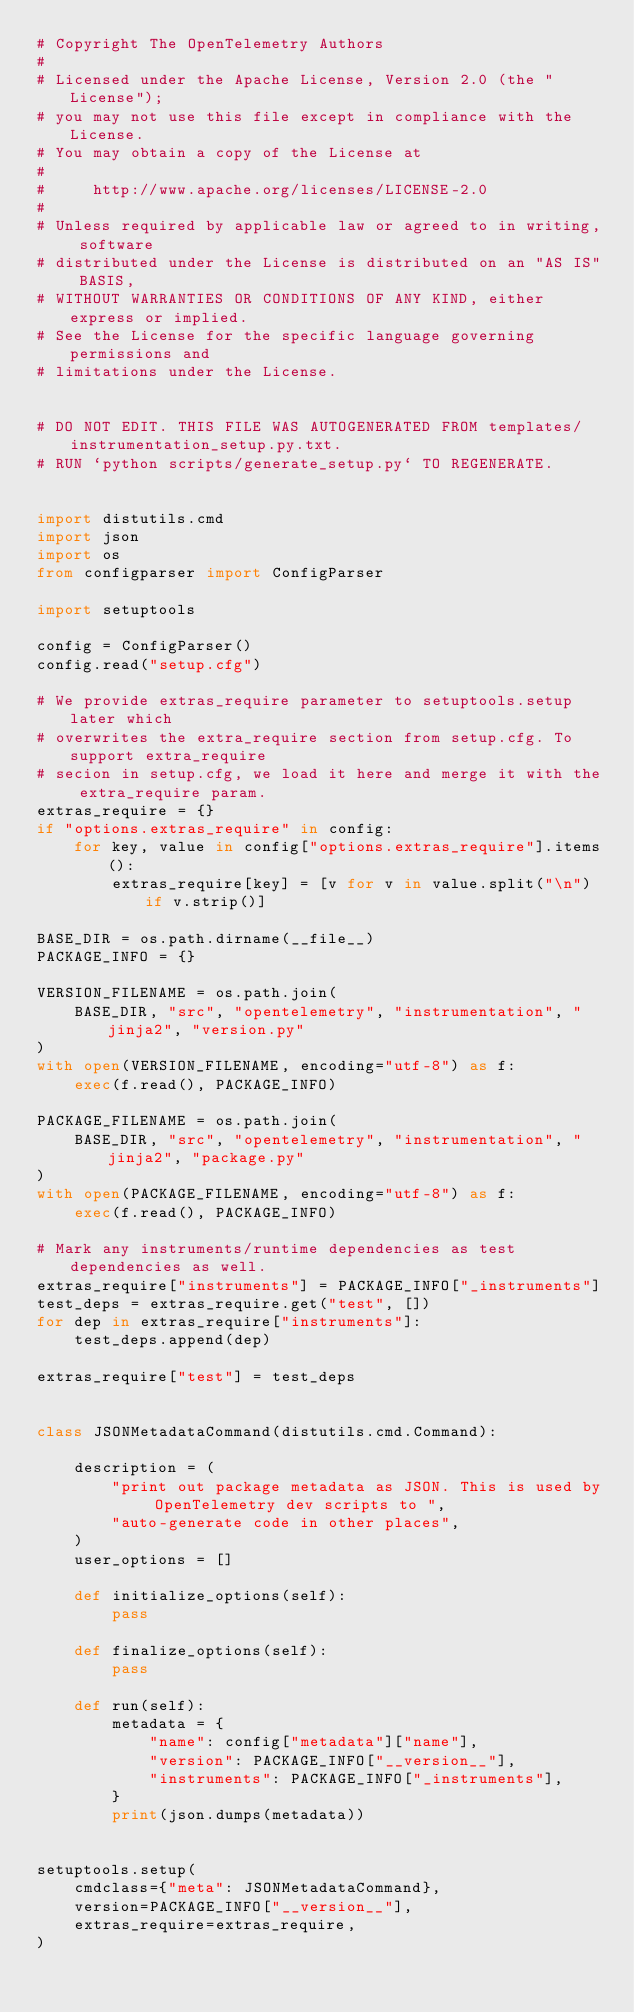Convert code to text. <code><loc_0><loc_0><loc_500><loc_500><_Python_># Copyright The OpenTelemetry Authors
#
# Licensed under the Apache License, Version 2.0 (the "License");
# you may not use this file except in compliance with the License.
# You may obtain a copy of the License at
#
#     http://www.apache.org/licenses/LICENSE-2.0
#
# Unless required by applicable law or agreed to in writing, software
# distributed under the License is distributed on an "AS IS" BASIS,
# WITHOUT WARRANTIES OR CONDITIONS OF ANY KIND, either express or implied.
# See the License for the specific language governing permissions and
# limitations under the License.


# DO NOT EDIT. THIS FILE WAS AUTOGENERATED FROM templates/instrumentation_setup.py.txt.
# RUN `python scripts/generate_setup.py` TO REGENERATE.


import distutils.cmd
import json
import os
from configparser import ConfigParser

import setuptools

config = ConfigParser()
config.read("setup.cfg")

# We provide extras_require parameter to setuptools.setup later which
# overwrites the extra_require section from setup.cfg. To support extra_require
# secion in setup.cfg, we load it here and merge it with the extra_require param.
extras_require = {}
if "options.extras_require" in config:
    for key, value in config["options.extras_require"].items():
        extras_require[key] = [v for v in value.split("\n") if v.strip()]

BASE_DIR = os.path.dirname(__file__)
PACKAGE_INFO = {}

VERSION_FILENAME = os.path.join(
    BASE_DIR, "src", "opentelemetry", "instrumentation", "jinja2", "version.py"
)
with open(VERSION_FILENAME, encoding="utf-8") as f:
    exec(f.read(), PACKAGE_INFO)

PACKAGE_FILENAME = os.path.join(
    BASE_DIR, "src", "opentelemetry", "instrumentation", "jinja2", "package.py"
)
with open(PACKAGE_FILENAME, encoding="utf-8") as f:
    exec(f.read(), PACKAGE_INFO)

# Mark any instruments/runtime dependencies as test dependencies as well.
extras_require["instruments"] = PACKAGE_INFO["_instruments"]
test_deps = extras_require.get("test", [])
for dep in extras_require["instruments"]:
    test_deps.append(dep)

extras_require["test"] = test_deps


class JSONMetadataCommand(distutils.cmd.Command):

    description = (
        "print out package metadata as JSON. This is used by OpenTelemetry dev scripts to ",
        "auto-generate code in other places",
    )
    user_options = []

    def initialize_options(self):
        pass

    def finalize_options(self):
        pass

    def run(self):
        metadata = {
            "name": config["metadata"]["name"],
            "version": PACKAGE_INFO["__version__"],
            "instruments": PACKAGE_INFO["_instruments"],
        }
        print(json.dumps(metadata))


setuptools.setup(
    cmdclass={"meta": JSONMetadataCommand},
    version=PACKAGE_INFO["__version__"],
    extras_require=extras_require,
)
</code> 